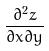Convert formula to latex. <formula><loc_0><loc_0><loc_500><loc_500>\frac { \partial ^ { 2 } z } { \partial x \partial y }</formula> 